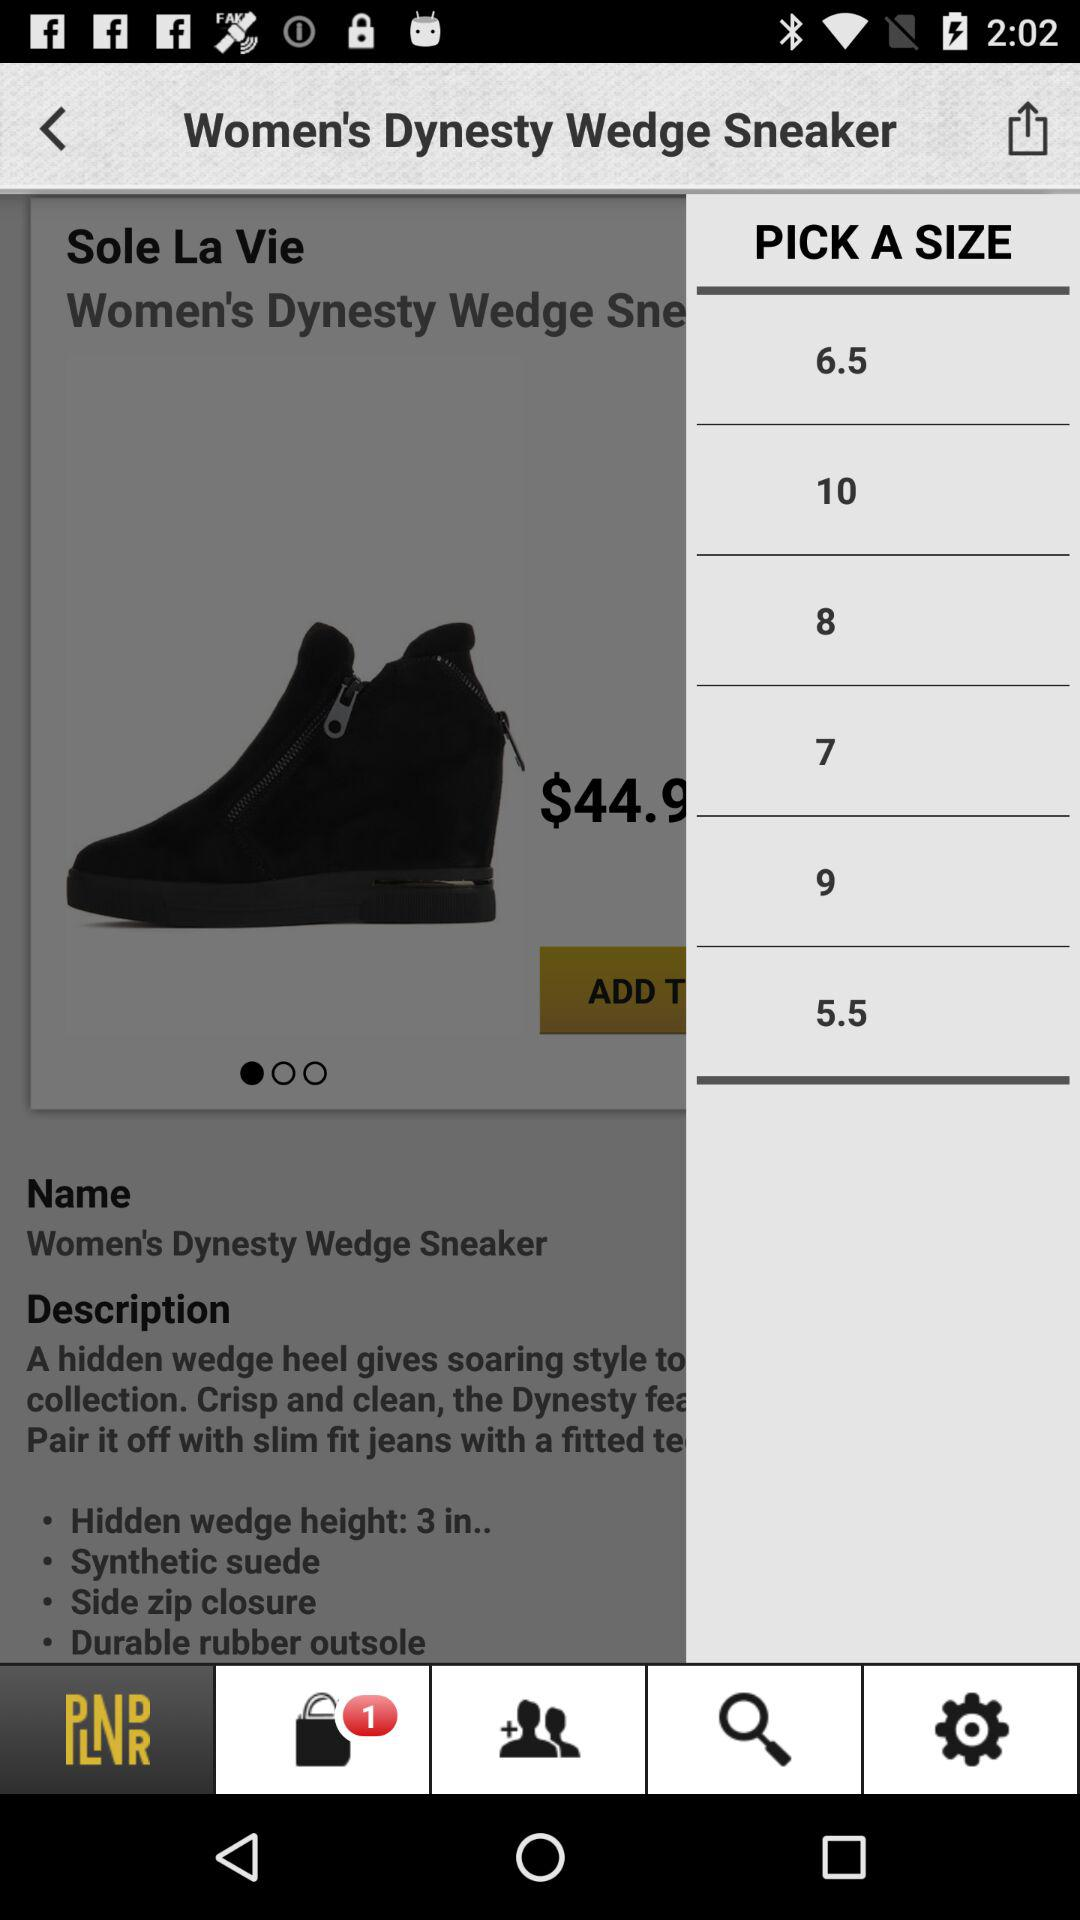What is the total price of the Sole La Vie Women's Dynasty Wedge Sneaker?
Answer the question using a single word or phrase. $44.9 